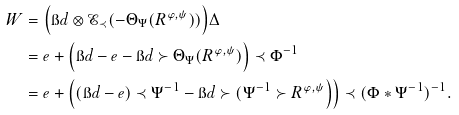<formula> <loc_0><loc_0><loc_500><loc_500>W & = \Big ( { \i d } \otimes \mathcal { E } _ { \prec } ( - \Theta _ { \Psi } ( R ^ { \varphi , \psi } ) ) \Big ) \Delta \\ & = e + \Big ( \i d - e - \i d \succ \Theta _ { \Psi } ( R ^ { \varphi , \psi } ) \Big ) \prec \Phi ^ { - 1 } \\ & = e + \Big ( ( \i d - e ) \prec \Psi ^ { - 1 } - \i d \succ ( \Psi ^ { - 1 } \succ R ^ { \varphi , \psi } \Big ) \Big ) \prec ( \Phi * \Psi ^ { - 1 } ) ^ { - 1 } .</formula> 